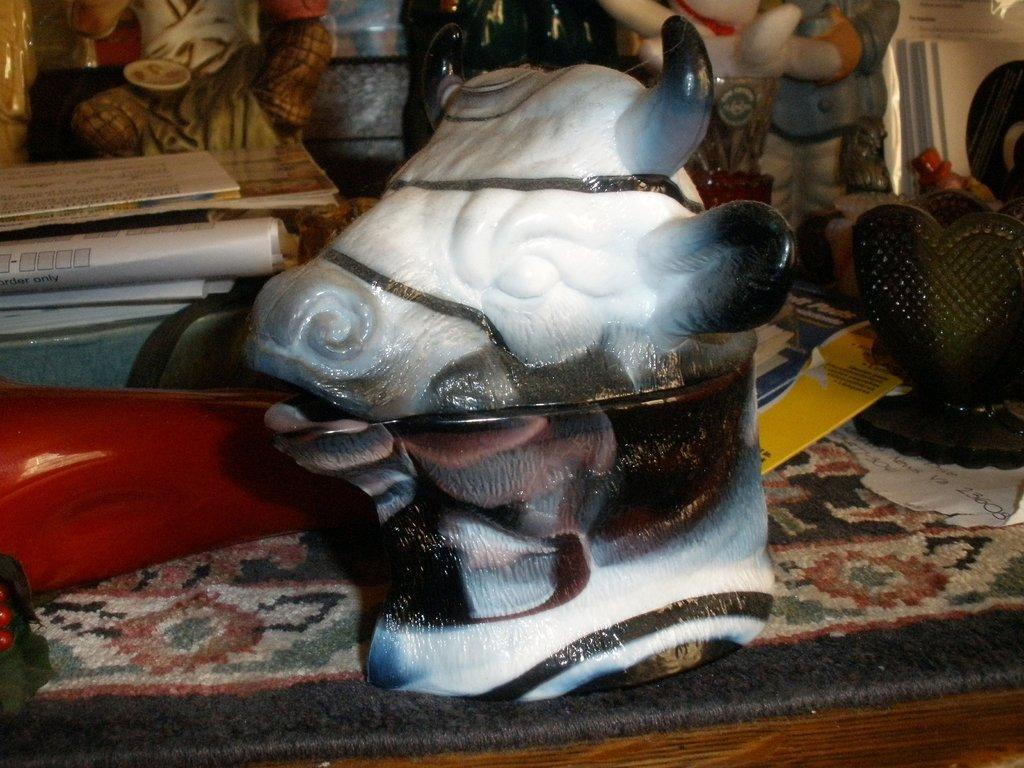In one or two sentences, can you explain what this image depicts? In this picture we can see a sculpture on a carpet and behind the carpet there are papers and other things and the carpet is a wooden object. 